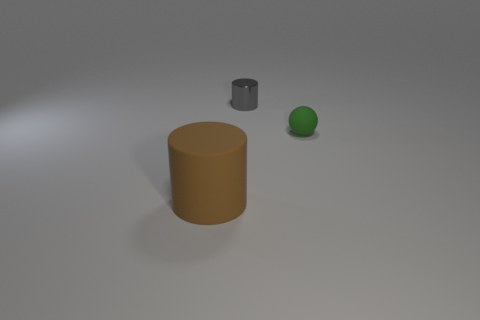Are there any other things that are the same shape as the green matte object?
Your response must be concise. No. What number of things are objects that are in front of the small metal cylinder or cylinders that are in front of the small gray shiny object?
Your answer should be compact. 2. There is a thing that is both in front of the gray metallic cylinder and to the left of the tiny green object; what size is it?
Your response must be concise. Large. There is a tiny object behind the tiny green rubber thing; is it the same shape as the brown rubber object?
Your answer should be very brief. Yes. There is a cylinder in front of the object behind the rubber object that is behind the large cylinder; what size is it?
Your answer should be very brief. Large. How many objects are either small gray shiny cylinders or gray metallic spheres?
Give a very brief answer. 1. The thing that is in front of the metallic thing and to the right of the brown thing has what shape?
Your answer should be very brief. Sphere. There is a gray metallic object; is its shape the same as the rubber thing that is to the left of the small green sphere?
Offer a very short reply. Yes. Are there any gray cylinders to the left of the gray thing?
Offer a very short reply. No. How many cylinders are either brown matte objects or matte things?
Keep it short and to the point. 1. 